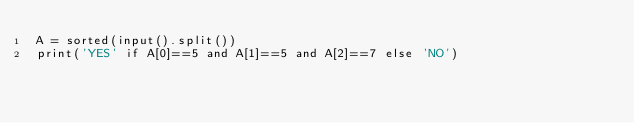<code> <loc_0><loc_0><loc_500><loc_500><_Python_>A = sorted(input().split())
print('YES' if A[0]==5 and A[1]==5 and A[2]==7 else 'NO')
</code> 